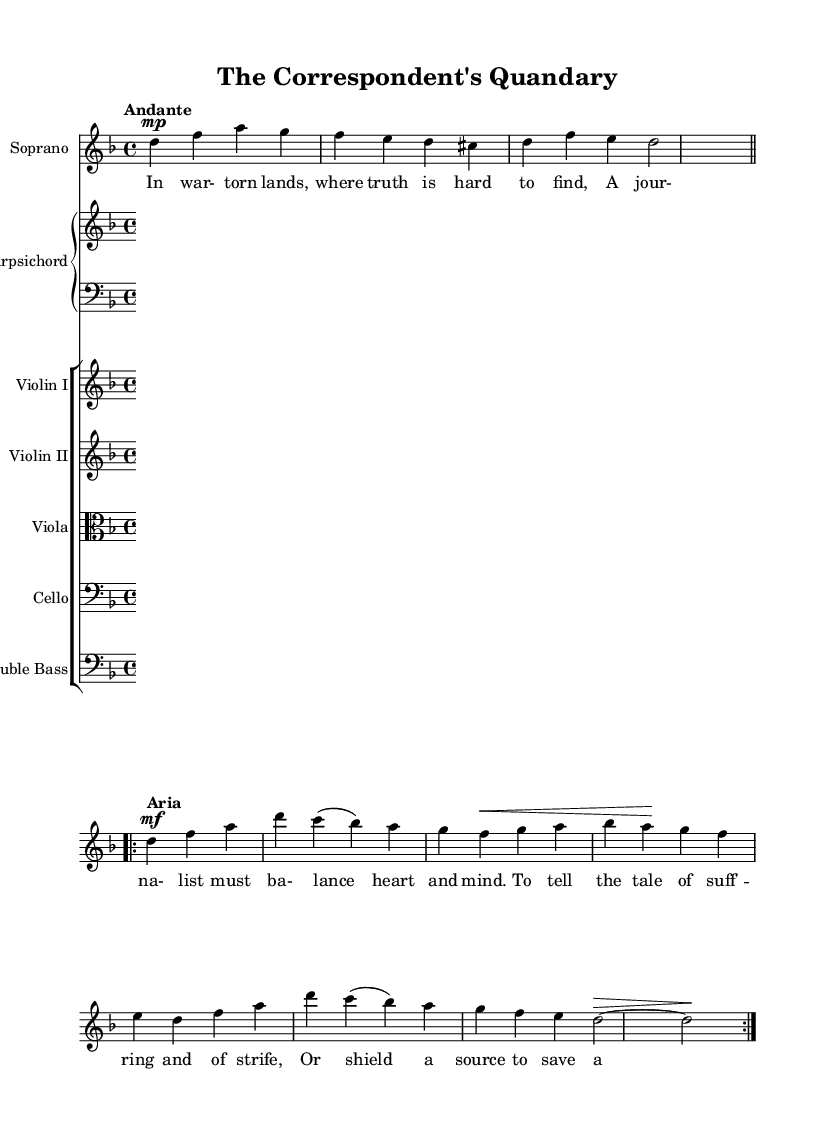What is the key signature of this music? The key signature is D minor, which has one flat (B flat). The key is indicated at the beginning of the score, directly after the clef.
Answer: D minor What is the time signature of this piece? The time signature is 4/4, meaning there are four beats in each measure. It is found at the beginning of the score also, right after the key signature.
Answer: 4/4 What is the specified tempo marking? The tempo marking is "Andante," suggesting a moderate pace. This marking is located at the beginning of the score.
Answer: Andante How many sections are indicated in the soprano part? There are two sections indicated: Recitative and Aria. They are labeled within the soprano part of the score, which helps differentiate the musical dialogue from the more melodic singing.
Answer: Two Which instruments are involved in this composition? The instruments involved are Soprano, Harpsichord, Violin I, Violin II, Viola, Cello, and Double Bass. This is noted at the start of each staff, where instrument names are provided.
Answer: Soprano, Harpsichord, Violin I, Violin II, Viola, Cello, Double Bass What dynamics are indicated in the soprano part? The dynamics indicated are "mp" (mezzo-piano) and "mf" (mezzo-forte), showing varying levels of volume in the performance. These dynamics are marked in the respect of certain notes within the soprano part.
Answer: mp, mf What thematic issue does the lyric of the soprano discuss? The lyric addresses the ethical dilemmas faced by a journalist in war-torn lands, balancing between truth-telling and protecting sources. The thematic context is clearly reflected in the words written below the soprano part.
Answer: Ethical dilemmas 